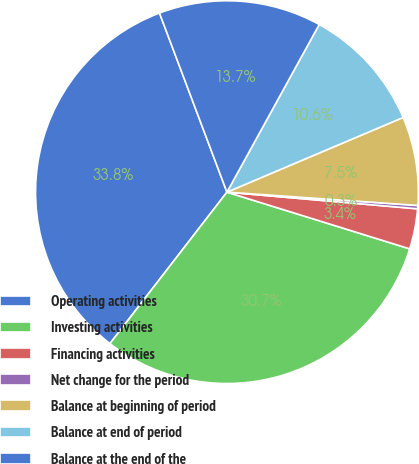<chart> <loc_0><loc_0><loc_500><loc_500><pie_chart><fcel>Operating activities<fcel>Investing activities<fcel>Financing activities<fcel>Net change for the period<fcel>Balance at beginning of period<fcel>Balance at end of period<fcel>Balance at the end of the<nl><fcel>33.8%<fcel>30.68%<fcel>3.4%<fcel>0.28%<fcel>7.49%<fcel>10.61%<fcel>13.74%<nl></chart> 